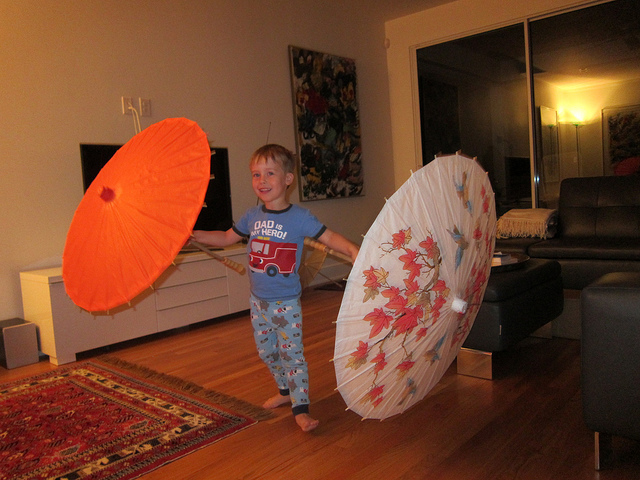Identify the text displayed in this image. DAD HERO 